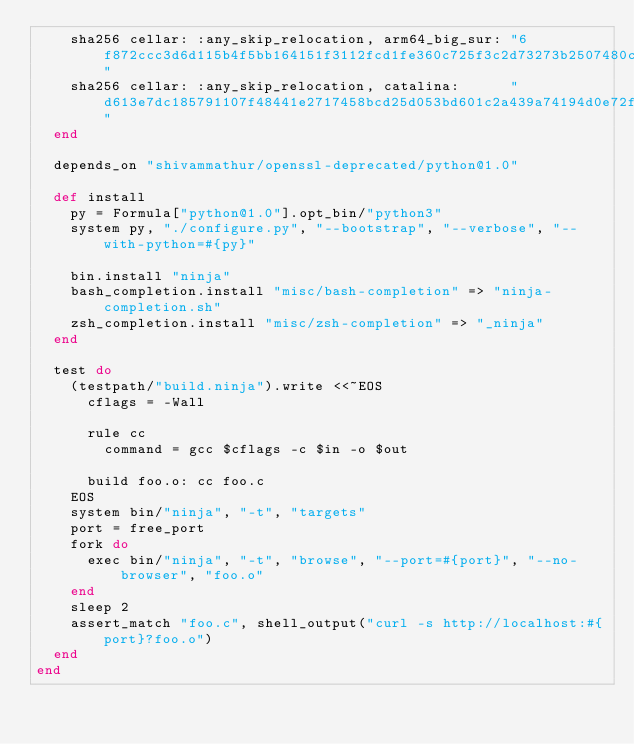<code> <loc_0><loc_0><loc_500><loc_500><_Ruby_>    sha256 cellar: :any_skip_relocation, arm64_big_sur: "6f872ccc3d6d115b4f5bb164151f3112fcd1fe360c725f3c2d73273b2507480c"
    sha256 cellar: :any_skip_relocation, catalina:      "d613e7dc185791107f48441e2717458bcd25d053bd601c2a439a74194d0e72f7"
  end

  depends_on "shivammathur/openssl-deprecated/python@1.0"

  def install
    py = Formula["python@1.0"].opt_bin/"python3"
    system py, "./configure.py", "--bootstrap", "--verbose", "--with-python=#{py}"

    bin.install "ninja"
    bash_completion.install "misc/bash-completion" => "ninja-completion.sh"
    zsh_completion.install "misc/zsh-completion" => "_ninja"
  end

  test do
    (testpath/"build.ninja").write <<~EOS
      cflags = -Wall

      rule cc
        command = gcc $cflags -c $in -o $out

      build foo.o: cc foo.c
    EOS
    system bin/"ninja", "-t", "targets"
    port = free_port
    fork do
      exec bin/"ninja", "-t", "browse", "--port=#{port}", "--no-browser", "foo.o"
    end
    sleep 2
    assert_match "foo.c", shell_output("curl -s http://localhost:#{port}?foo.o")
  end
end
</code> 